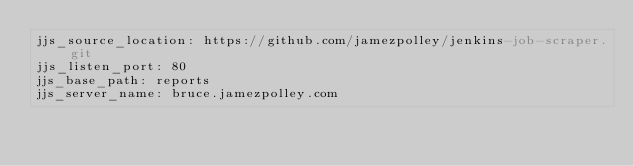Convert code to text. <code><loc_0><loc_0><loc_500><loc_500><_YAML_>jjs_source_location: https://github.com/jamezpolley/jenkins-job-scraper.git
jjs_listen_port: 80
jjs_base_path: reports
jjs_server_name: bruce.jamezpolley.com</code> 